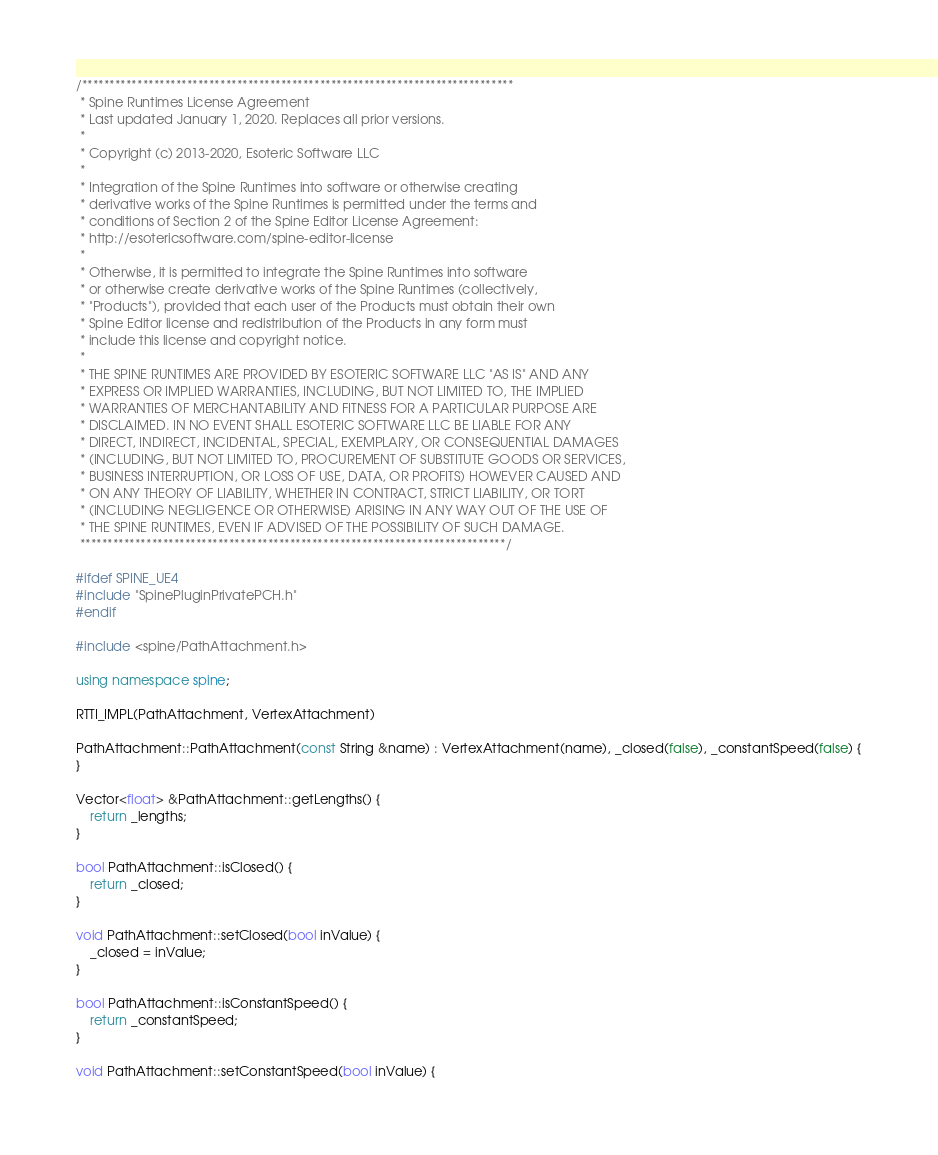Convert code to text. <code><loc_0><loc_0><loc_500><loc_500><_C++_>/******************************************************************************
 * Spine Runtimes License Agreement
 * Last updated January 1, 2020. Replaces all prior versions.
 *
 * Copyright (c) 2013-2020, Esoteric Software LLC
 *
 * Integration of the Spine Runtimes into software or otherwise creating
 * derivative works of the Spine Runtimes is permitted under the terms and
 * conditions of Section 2 of the Spine Editor License Agreement:
 * http://esotericsoftware.com/spine-editor-license
 *
 * Otherwise, it is permitted to integrate the Spine Runtimes into software
 * or otherwise create derivative works of the Spine Runtimes (collectively,
 * "Products"), provided that each user of the Products must obtain their own
 * Spine Editor license and redistribution of the Products in any form must
 * include this license and copyright notice.
 *
 * THE SPINE RUNTIMES ARE PROVIDED BY ESOTERIC SOFTWARE LLC "AS IS" AND ANY
 * EXPRESS OR IMPLIED WARRANTIES, INCLUDING, BUT NOT LIMITED TO, THE IMPLIED
 * WARRANTIES OF MERCHANTABILITY AND FITNESS FOR A PARTICULAR PURPOSE ARE
 * DISCLAIMED. IN NO EVENT SHALL ESOTERIC SOFTWARE LLC BE LIABLE FOR ANY
 * DIRECT, INDIRECT, INCIDENTAL, SPECIAL, EXEMPLARY, OR CONSEQUENTIAL DAMAGES
 * (INCLUDING, BUT NOT LIMITED TO, PROCUREMENT OF SUBSTITUTE GOODS OR SERVICES,
 * BUSINESS INTERRUPTION, OR LOSS OF USE, DATA, OR PROFITS) HOWEVER CAUSED AND
 * ON ANY THEORY OF LIABILITY, WHETHER IN CONTRACT, STRICT LIABILITY, OR TORT
 * (INCLUDING NEGLIGENCE OR OTHERWISE) ARISING IN ANY WAY OUT OF THE USE OF
 * THE SPINE RUNTIMES, EVEN IF ADVISED OF THE POSSIBILITY OF SUCH DAMAGE.
 *****************************************************************************/

#ifdef SPINE_UE4
#include "SpinePluginPrivatePCH.h"
#endif

#include <spine/PathAttachment.h>

using namespace spine;

RTTI_IMPL(PathAttachment, VertexAttachment)

PathAttachment::PathAttachment(const String &name) : VertexAttachment(name), _closed(false), _constantSpeed(false) {
}

Vector<float> &PathAttachment::getLengths() {
	return _lengths;
}

bool PathAttachment::isClosed() {
	return _closed;
}

void PathAttachment::setClosed(bool inValue) {
	_closed = inValue;
}

bool PathAttachment::isConstantSpeed() {
	return _constantSpeed;
}

void PathAttachment::setConstantSpeed(bool inValue) {</code> 